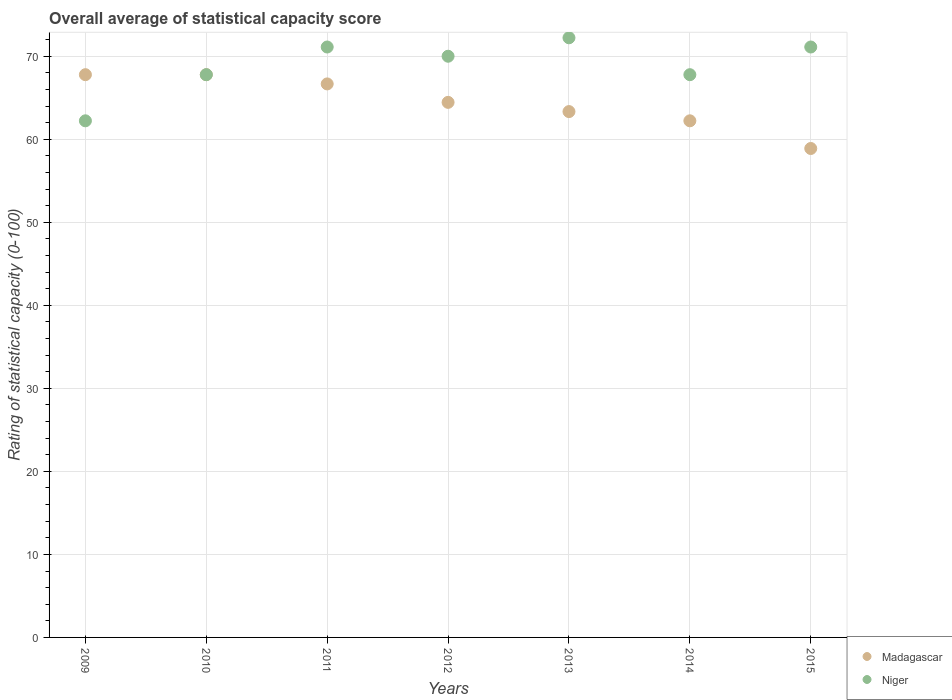How many different coloured dotlines are there?
Your answer should be very brief. 2. Is the number of dotlines equal to the number of legend labels?
Ensure brevity in your answer.  Yes. What is the rating of statistical capacity in Niger in 2011?
Your response must be concise. 71.11. Across all years, what is the maximum rating of statistical capacity in Madagascar?
Provide a short and direct response. 67.78. Across all years, what is the minimum rating of statistical capacity in Niger?
Your response must be concise. 62.22. In which year was the rating of statistical capacity in Madagascar minimum?
Make the answer very short. 2015. What is the total rating of statistical capacity in Madagascar in the graph?
Keep it short and to the point. 451.11. What is the difference between the rating of statistical capacity in Niger in 2013 and that in 2014?
Offer a very short reply. 4.44. What is the difference between the rating of statistical capacity in Madagascar in 2015 and the rating of statistical capacity in Niger in 2010?
Your answer should be compact. -8.89. What is the average rating of statistical capacity in Madagascar per year?
Keep it short and to the point. 64.44. In the year 2015, what is the difference between the rating of statistical capacity in Niger and rating of statistical capacity in Madagascar?
Ensure brevity in your answer.  12.22. In how many years, is the rating of statistical capacity in Madagascar greater than 64?
Offer a terse response. 4. What is the ratio of the rating of statistical capacity in Niger in 2012 to that in 2015?
Offer a very short reply. 0.98. Is the difference between the rating of statistical capacity in Niger in 2012 and 2013 greater than the difference between the rating of statistical capacity in Madagascar in 2012 and 2013?
Your answer should be very brief. No. What is the difference between the highest and the second highest rating of statistical capacity in Niger?
Your response must be concise. 1.11. What is the difference between the highest and the lowest rating of statistical capacity in Madagascar?
Your answer should be compact. 8.89. Is the sum of the rating of statistical capacity in Niger in 2011 and 2013 greater than the maximum rating of statistical capacity in Madagascar across all years?
Your response must be concise. Yes. Is the rating of statistical capacity in Niger strictly greater than the rating of statistical capacity in Madagascar over the years?
Provide a succinct answer. No. Are the values on the major ticks of Y-axis written in scientific E-notation?
Offer a very short reply. No. How are the legend labels stacked?
Provide a succinct answer. Vertical. What is the title of the graph?
Give a very brief answer. Overall average of statistical capacity score. Does "Sub-Saharan Africa (developing only)" appear as one of the legend labels in the graph?
Keep it short and to the point. No. What is the label or title of the Y-axis?
Offer a very short reply. Rating of statistical capacity (0-100). What is the Rating of statistical capacity (0-100) of Madagascar in 2009?
Keep it short and to the point. 67.78. What is the Rating of statistical capacity (0-100) of Niger in 2009?
Provide a succinct answer. 62.22. What is the Rating of statistical capacity (0-100) in Madagascar in 2010?
Offer a terse response. 67.78. What is the Rating of statistical capacity (0-100) of Niger in 2010?
Ensure brevity in your answer.  67.78. What is the Rating of statistical capacity (0-100) of Madagascar in 2011?
Make the answer very short. 66.67. What is the Rating of statistical capacity (0-100) in Niger in 2011?
Provide a succinct answer. 71.11. What is the Rating of statistical capacity (0-100) in Madagascar in 2012?
Offer a very short reply. 64.44. What is the Rating of statistical capacity (0-100) of Madagascar in 2013?
Your response must be concise. 63.33. What is the Rating of statistical capacity (0-100) in Niger in 2013?
Your response must be concise. 72.22. What is the Rating of statistical capacity (0-100) of Madagascar in 2014?
Ensure brevity in your answer.  62.22. What is the Rating of statistical capacity (0-100) of Niger in 2014?
Provide a short and direct response. 67.78. What is the Rating of statistical capacity (0-100) of Madagascar in 2015?
Provide a succinct answer. 58.89. What is the Rating of statistical capacity (0-100) of Niger in 2015?
Provide a succinct answer. 71.11. Across all years, what is the maximum Rating of statistical capacity (0-100) of Madagascar?
Provide a short and direct response. 67.78. Across all years, what is the maximum Rating of statistical capacity (0-100) of Niger?
Offer a very short reply. 72.22. Across all years, what is the minimum Rating of statistical capacity (0-100) of Madagascar?
Your response must be concise. 58.89. Across all years, what is the minimum Rating of statistical capacity (0-100) of Niger?
Give a very brief answer. 62.22. What is the total Rating of statistical capacity (0-100) in Madagascar in the graph?
Offer a terse response. 451.11. What is the total Rating of statistical capacity (0-100) of Niger in the graph?
Ensure brevity in your answer.  482.22. What is the difference between the Rating of statistical capacity (0-100) in Madagascar in 2009 and that in 2010?
Provide a short and direct response. 0. What is the difference between the Rating of statistical capacity (0-100) of Niger in 2009 and that in 2010?
Your answer should be compact. -5.56. What is the difference between the Rating of statistical capacity (0-100) in Madagascar in 2009 and that in 2011?
Your answer should be compact. 1.11. What is the difference between the Rating of statistical capacity (0-100) of Niger in 2009 and that in 2011?
Give a very brief answer. -8.89. What is the difference between the Rating of statistical capacity (0-100) in Niger in 2009 and that in 2012?
Your response must be concise. -7.78. What is the difference between the Rating of statistical capacity (0-100) in Madagascar in 2009 and that in 2013?
Make the answer very short. 4.44. What is the difference between the Rating of statistical capacity (0-100) of Niger in 2009 and that in 2013?
Keep it short and to the point. -10. What is the difference between the Rating of statistical capacity (0-100) of Madagascar in 2009 and that in 2014?
Ensure brevity in your answer.  5.56. What is the difference between the Rating of statistical capacity (0-100) in Niger in 2009 and that in 2014?
Ensure brevity in your answer.  -5.56. What is the difference between the Rating of statistical capacity (0-100) in Madagascar in 2009 and that in 2015?
Your answer should be very brief. 8.89. What is the difference between the Rating of statistical capacity (0-100) in Niger in 2009 and that in 2015?
Offer a terse response. -8.89. What is the difference between the Rating of statistical capacity (0-100) of Madagascar in 2010 and that in 2012?
Offer a terse response. 3.33. What is the difference between the Rating of statistical capacity (0-100) in Niger in 2010 and that in 2012?
Offer a very short reply. -2.22. What is the difference between the Rating of statistical capacity (0-100) of Madagascar in 2010 and that in 2013?
Offer a terse response. 4.44. What is the difference between the Rating of statistical capacity (0-100) of Niger in 2010 and that in 2013?
Provide a succinct answer. -4.44. What is the difference between the Rating of statistical capacity (0-100) in Madagascar in 2010 and that in 2014?
Provide a short and direct response. 5.56. What is the difference between the Rating of statistical capacity (0-100) of Niger in 2010 and that in 2014?
Ensure brevity in your answer.  0. What is the difference between the Rating of statistical capacity (0-100) in Madagascar in 2010 and that in 2015?
Offer a terse response. 8.89. What is the difference between the Rating of statistical capacity (0-100) of Niger in 2010 and that in 2015?
Offer a terse response. -3.33. What is the difference between the Rating of statistical capacity (0-100) of Madagascar in 2011 and that in 2012?
Give a very brief answer. 2.22. What is the difference between the Rating of statistical capacity (0-100) in Niger in 2011 and that in 2012?
Make the answer very short. 1.11. What is the difference between the Rating of statistical capacity (0-100) of Madagascar in 2011 and that in 2013?
Provide a short and direct response. 3.33. What is the difference between the Rating of statistical capacity (0-100) of Niger in 2011 and that in 2013?
Ensure brevity in your answer.  -1.11. What is the difference between the Rating of statistical capacity (0-100) in Madagascar in 2011 and that in 2014?
Ensure brevity in your answer.  4.44. What is the difference between the Rating of statistical capacity (0-100) of Madagascar in 2011 and that in 2015?
Provide a succinct answer. 7.78. What is the difference between the Rating of statistical capacity (0-100) of Madagascar in 2012 and that in 2013?
Your answer should be compact. 1.11. What is the difference between the Rating of statistical capacity (0-100) of Niger in 2012 and that in 2013?
Your response must be concise. -2.22. What is the difference between the Rating of statistical capacity (0-100) of Madagascar in 2012 and that in 2014?
Keep it short and to the point. 2.22. What is the difference between the Rating of statistical capacity (0-100) in Niger in 2012 and that in 2014?
Your answer should be very brief. 2.22. What is the difference between the Rating of statistical capacity (0-100) in Madagascar in 2012 and that in 2015?
Offer a very short reply. 5.56. What is the difference between the Rating of statistical capacity (0-100) in Niger in 2012 and that in 2015?
Your answer should be compact. -1.11. What is the difference between the Rating of statistical capacity (0-100) of Niger in 2013 and that in 2014?
Keep it short and to the point. 4.44. What is the difference between the Rating of statistical capacity (0-100) in Madagascar in 2013 and that in 2015?
Your answer should be compact. 4.44. What is the difference between the Rating of statistical capacity (0-100) of Niger in 2014 and that in 2015?
Give a very brief answer. -3.33. What is the difference between the Rating of statistical capacity (0-100) of Madagascar in 2009 and the Rating of statistical capacity (0-100) of Niger in 2012?
Provide a short and direct response. -2.22. What is the difference between the Rating of statistical capacity (0-100) in Madagascar in 2009 and the Rating of statistical capacity (0-100) in Niger in 2013?
Your response must be concise. -4.44. What is the difference between the Rating of statistical capacity (0-100) of Madagascar in 2009 and the Rating of statistical capacity (0-100) of Niger in 2014?
Make the answer very short. 0. What is the difference between the Rating of statistical capacity (0-100) of Madagascar in 2009 and the Rating of statistical capacity (0-100) of Niger in 2015?
Provide a succinct answer. -3.33. What is the difference between the Rating of statistical capacity (0-100) in Madagascar in 2010 and the Rating of statistical capacity (0-100) in Niger in 2012?
Your answer should be compact. -2.22. What is the difference between the Rating of statistical capacity (0-100) in Madagascar in 2010 and the Rating of statistical capacity (0-100) in Niger in 2013?
Keep it short and to the point. -4.44. What is the difference between the Rating of statistical capacity (0-100) of Madagascar in 2010 and the Rating of statistical capacity (0-100) of Niger in 2014?
Provide a succinct answer. 0. What is the difference between the Rating of statistical capacity (0-100) of Madagascar in 2010 and the Rating of statistical capacity (0-100) of Niger in 2015?
Make the answer very short. -3.33. What is the difference between the Rating of statistical capacity (0-100) in Madagascar in 2011 and the Rating of statistical capacity (0-100) in Niger in 2013?
Your answer should be very brief. -5.56. What is the difference between the Rating of statistical capacity (0-100) of Madagascar in 2011 and the Rating of statistical capacity (0-100) of Niger in 2014?
Keep it short and to the point. -1.11. What is the difference between the Rating of statistical capacity (0-100) of Madagascar in 2011 and the Rating of statistical capacity (0-100) of Niger in 2015?
Give a very brief answer. -4.44. What is the difference between the Rating of statistical capacity (0-100) in Madagascar in 2012 and the Rating of statistical capacity (0-100) in Niger in 2013?
Provide a short and direct response. -7.78. What is the difference between the Rating of statistical capacity (0-100) in Madagascar in 2012 and the Rating of statistical capacity (0-100) in Niger in 2014?
Give a very brief answer. -3.33. What is the difference between the Rating of statistical capacity (0-100) in Madagascar in 2012 and the Rating of statistical capacity (0-100) in Niger in 2015?
Offer a very short reply. -6.67. What is the difference between the Rating of statistical capacity (0-100) of Madagascar in 2013 and the Rating of statistical capacity (0-100) of Niger in 2014?
Your answer should be very brief. -4.44. What is the difference between the Rating of statistical capacity (0-100) in Madagascar in 2013 and the Rating of statistical capacity (0-100) in Niger in 2015?
Your answer should be very brief. -7.78. What is the difference between the Rating of statistical capacity (0-100) in Madagascar in 2014 and the Rating of statistical capacity (0-100) in Niger in 2015?
Your answer should be compact. -8.89. What is the average Rating of statistical capacity (0-100) of Madagascar per year?
Provide a short and direct response. 64.44. What is the average Rating of statistical capacity (0-100) in Niger per year?
Your response must be concise. 68.89. In the year 2009, what is the difference between the Rating of statistical capacity (0-100) in Madagascar and Rating of statistical capacity (0-100) in Niger?
Make the answer very short. 5.56. In the year 2010, what is the difference between the Rating of statistical capacity (0-100) of Madagascar and Rating of statistical capacity (0-100) of Niger?
Provide a short and direct response. 0. In the year 2011, what is the difference between the Rating of statistical capacity (0-100) in Madagascar and Rating of statistical capacity (0-100) in Niger?
Provide a succinct answer. -4.44. In the year 2012, what is the difference between the Rating of statistical capacity (0-100) in Madagascar and Rating of statistical capacity (0-100) in Niger?
Your response must be concise. -5.56. In the year 2013, what is the difference between the Rating of statistical capacity (0-100) in Madagascar and Rating of statistical capacity (0-100) in Niger?
Ensure brevity in your answer.  -8.89. In the year 2014, what is the difference between the Rating of statistical capacity (0-100) in Madagascar and Rating of statistical capacity (0-100) in Niger?
Your answer should be very brief. -5.56. In the year 2015, what is the difference between the Rating of statistical capacity (0-100) of Madagascar and Rating of statistical capacity (0-100) of Niger?
Provide a short and direct response. -12.22. What is the ratio of the Rating of statistical capacity (0-100) of Madagascar in 2009 to that in 2010?
Your answer should be very brief. 1. What is the ratio of the Rating of statistical capacity (0-100) in Niger in 2009 to that in 2010?
Your answer should be compact. 0.92. What is the ratio of the Rating of statistical capacity (0-100) in Madagascar in 2009 to that in 2011?
Your answer should be very brief. 1.02. What is the ratio of the Rating of statistical capacity (0-100) in Madagascar in 2009 to that in 2012?
Give a very brief answer. 1.05. What is the ratio of the Rating of statistical capacity (0-100) of Madagascar in 2009 to that in 2013?
Your answer should be very brief. 1.07. What is the ratio of the Rating of statistical capacity (0-100) in Niger in 2009 to that in 2013?
Your answer should be compact. 0.86. What is the ratio of the Rating of statistical capacity (0-100) of Madagascar in 2009 to that in 2014?
Offer a terse response. 1.09. What is the ratio of the Rating of statistical capacity (0-100) in Niger in 2009 to that in 2014?
Your response must be concise. 0.92. What is the ratio of the Rating of statistical capacity (0-100) of Madagascar in 2009 to that in 2015?
Provide a short and direct response. 1.15. What is the ratio of the Rating of statistical capacity (0-100) of Niger in 2009 to that in 2015?
Offer a terse response. 0.88. What is the ratio of the Rating of statistical capacity (0-100) in Madagascar in 2010 to that in 2011?
Offer a terse response. 1.02. What is the ratio of the Rating of statistical capacity (0-100) in Niger in 2010 to that in 2011?
Offer a very short reply. 0.95. What is the ratio of the Rating of statistical capacity (0-100) of Madagascar in 2010 to that in 2012?
Ensure brevity in your answer.  1.05. What is the ratio of the Rating of statistical capacity (0-100) of Niger in 2010 to that in 2012?
Your answer should be compact. 0.97. What is the ratio of the Rating of statistical capacity (0-100) of Madagascar in 2010 to that in 2013?
Offer a terse response. 1.07. What is the ratio of the Rating of statistical capacity (0-100) of Niger in 2010 to that in 2013?
Offer a terse response. 0.94. What is the ratio of the Rating of statistical capacity (0-100) of Madagascar in 2010 to that in 2014?
Your answer should be compact. 1.09. What is the ratio of the Rating of statistical capacity (0-100) in Niger in 2010 to that in 2014?
Provide a succinct answer. 1. What is the ratio of the Rating of statistical capacity (0-100) of Madagascar in 2010 to that in 2015?
Keep it short and to the point. 1.15. What is the ratio of the Rating of statistical capacity (0-100) in Niger in 2010 to that in 2015?
Give a very brief answer. 0.95. What is the ratio of the Rating of statistical capacity (0-100) of Madagascar in 2011 to that in 2012?
Offer a very short reply. 1.03. What is the ratio of the Rating of statistical capacity (0-100) of Niger in 2011 to that in 2012?
Your response must be concise. 1.02. What is the ratio of the Rating of statistical capacity (0-100) in Madagascar in 2011 to that in 2013?
Your answer should be very brief. 1.05. What is the ratio of the Rating of statistical capacity (0-100) of Niger in 2011 to that in 2013?
Offer a very short reply. 0.98. What is the ratio of the Rating of statistical capacity (0-100) in Madagascar in 2011 to that in 2014?
Keep it short and to the point. 1.07. What is the ratio of the Rating of statistical capacity (0-100) of Niger in 2011 to that in 2014?
Give a very brief answer. 1.05. What is the ratio of the Rating of statistical capacity (0-100) of Madagascar in 2011 to that in 2015?
Your answer should be very brief. 1.13. What is the ratio of the Rating of statistical capacity (0-100) of Madagascar in 2012 to that in 2013?
Offer a terse response. 1.02. What is the ratio of the Rating of statistical capacity (0-100) in Niger in 2012 to that in 2013?
Provide a short and direct response. 0.97. What is the ratio of the Rating of statistical capacity (0-100) in Madagascar in 2012 to that in 2014?
Provide a short and direct response. 1.04. What is the ratio of the Rating of statistical capacity (0-100) of Niger in 2012 to that in 2014?
Provide a short and direct response. 1.03. What is the ratio of the Rating of statistical capacity (0-100) of Madagascar in 2012 to that in 2015?
Your response must be concise. 1.09. What is the ratio of the Rating of statistical capacity (0-100) in Niger in 2012 to that in 2015?
Provide a succinct answer. 0.98. What is the ratio of the Rating of statistical capacity (0-100) in Madagascar in 2013 to that in 2014?
Make the answer very short. 1.02. What is the ratio of the Rating of statistical capacity (0-100) of Niger in 2013 to that in 2014?
Give a very brief answer. 1.07. What is the ratio of the Rating of statistical capacity (0-100) of Madagascar in 2013 to that in 2015?
Offer a terse response. 1.08. What is the ratio of the Rating of statistical capacity (0-100) of Niger in 2013 to that in 2015?
Keep it short and to the point. 1.02. What is the ratio of the Rating of statistical capacity (0-100) in Madagascar in 2014 to that in 2015?
Ensure brevity in your answer.  1.06. What is the ratio of the Rating of statistical capacity (0-100) of Niger in 2014 to that in 2015?
Offer a terse response. 0.95. What is the difference between the highest and the lowest Rating of statistical capacity (0-100) of Madagascar?
Keep it short and to the point. 8.89. What is the difference between the highest and the lowest Rating of statistical capacity (0-100) in Niger?
Keep it short and to the point. 10. 